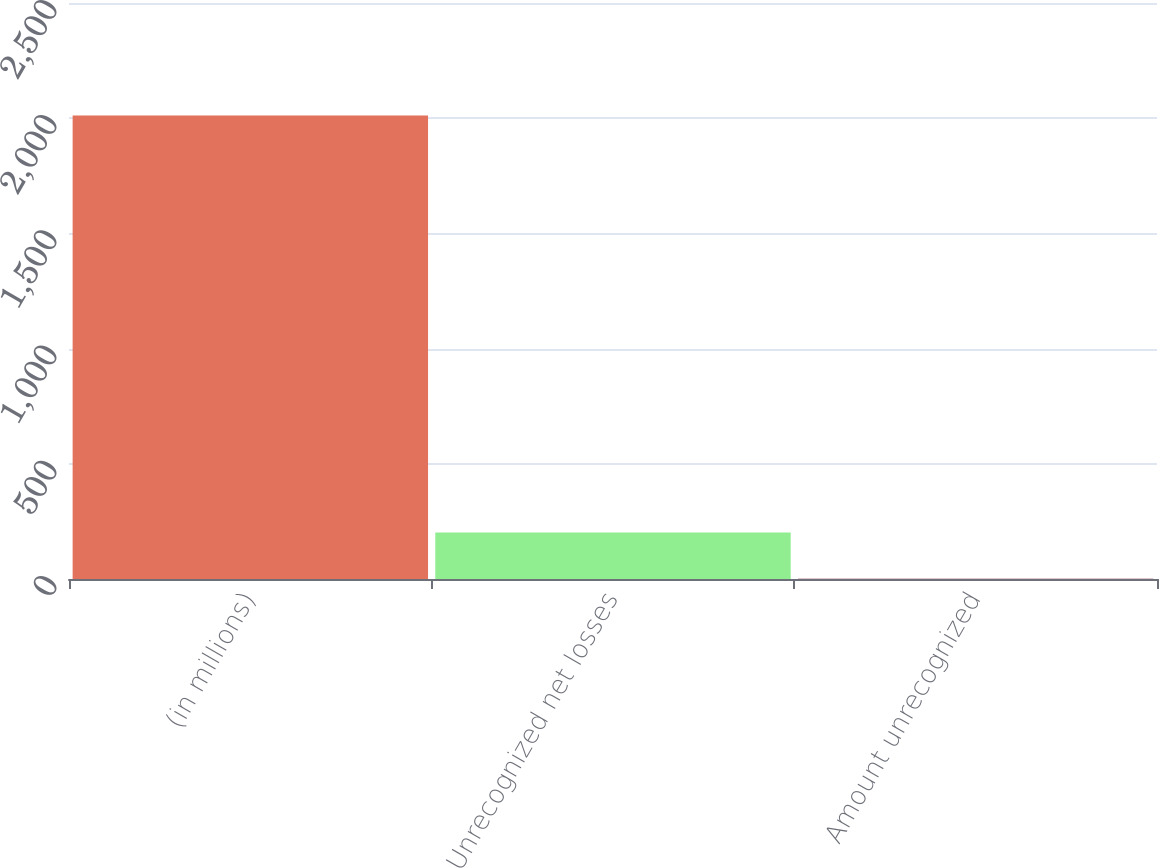<chart> <loc_0><loc_0><loc_500><loc_500><bar_chart><fcel>(in millions)<fcel>Unrecognized net losses<fcel>Amount unrecognized<nl><fcel>2012<fcel>202.1<fcel>1<nl></chart> 